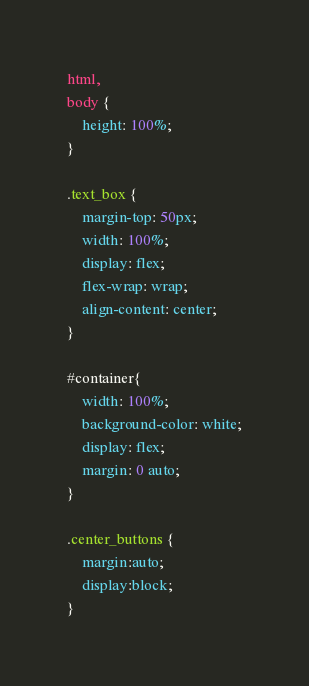Convert code to text. <code><loc_0><loc_0><loc_500><loc_500><_CSS_>html,
body {
    height: 100%;
}

.text_box {
    margin-top: 50px;
    width: 100%;
    display: flex;
    flex-wrap: wrap;
    align-content: center;
}

#container{
    width: 100%;
    background-color: white;
    display: flex;
    margin: 0 auto;
}

.center_buttons {
    margin:auto;
    display:block;
}
</code> 